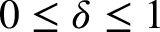Convert formula to latex. <formula><loc_0><loc_0><loc_500><loc_500>0 \leq \delta \leq 1</formula> 